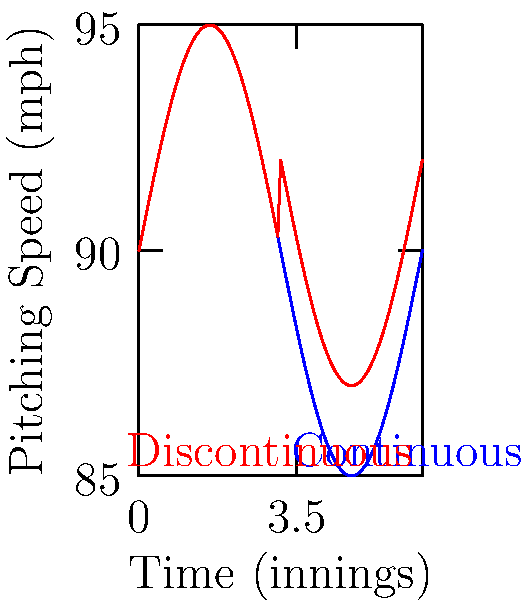The graph represents Kodai Sano's pitching speed over the course of a game. Which curve (blue or red) accurately represents a continuous function for Sano's pitching speed, and why? To determine which curve represents a continuous function for Kodai Sano's pitching speed, we need to analyze both curves:

1. Blue curve:
   - The blue curve appears smooth and unbroken throughout the entire domain.
   - There are no sudden jumps or gaps in the curve.
   - The function seems to oscillate smoothly, possibly representing natural variations in pitching speed.

2. Red curve:
   - The red curve follows a similar pattern to the blue curve for the first half of the domain.
   - However, at the midpoint (likely representing the middle of the game), there's a sudden jump in the curve.
   - This jump creates a discontinuity, as the function value changes abruptly without a smooth transition.

3. Continuity definition:
   A function is continuous if it satisfies three conditions:
   a) The function is defined for all points in its domain.
   b) The limit of the function exists as we approach any point from both directions.
   c) The limit at any point equals the function value at that point.

4. Analysis:
   - The blue curve satisfies all three conditions for continuity. It's defined everywhere, has no sudden jumps, and the limit equals the function value at every point.
   - The red curve violates condition (b) and (c) at the point of the sudden jump. The limit from the left and right at this point are different, and the function value doesn't equal these limits.

Therefore, the blue curve accurately represents a continuous function for Sano's pitching speed.
Answer: Blue curve; it has no discontinuities. 